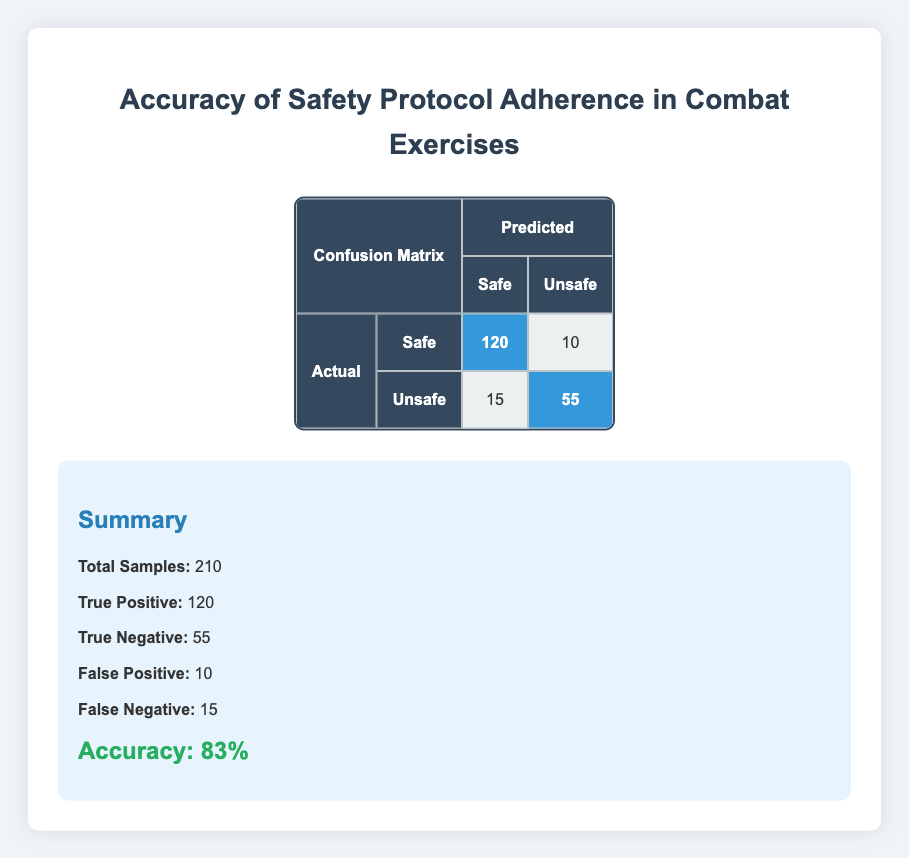What is the total number of samples? The total number of samples is provided directly in the summary section of the table. According to the data, the total samples are 210.
Answer: 210 How many instances were correctly predicted as safe? The number of instances that were correctly predicted as safe is labeled as True Positive in the summary. From the data, it states that the True Positive count is 120.
Answer: 120 What is the number of false negatives? The table lists the false negatives in the summary section. The count of false negatives is shown as 15 in the data provided.
Answer: 15 Did the model incorrectly classify any safe instances as unsafe? We can determine this by checking the False Positive in the summary, which indicates if safe instances were predicted as unsafe. The False Positive count is 10, which confirms that some safe instances were incorrectly classified.
Answer: Yes What is the overall accuracy of the model? The accuracy is given in the summary section of the table. It is calculated based on the formula for accuracy using the provided data. The accuracy here is stated as 83%.
Answer: 83% By how much does the True Positive exceed the False Negative? To find the difference, we subtract the False Negative count from the True Positive count. True Positive is 120 and False Negative is 15, so 120 - 15 = 105.
Answer: 105 What percentage of the total predictions were False Positives? The percentage of False Positives is found by dividing the number of False Positives by the total samples and multiplying by 100. Here it is (10 / 210) * 100 = 4.76%, which can be rounded as needed.
Answer: 4.76% If the predicted safe instances were accurate, what would be the expected safe instances? Expected safe instances would equal True Positive plus False Positive. So, the calculation is 120 (True Positive) + 10 (False Positive) = 130 expected safe instances if predictions were accurate.
Answer: 130 What is the total number of unsafe instances predicted? The total number of unsafe instances predicted includes both False Negative and True Negative. From the table, True Negative is 55, and False Negative is 15, summing up to 55 + 15 = 70 predicted unsafe instances.
Answer: 70 